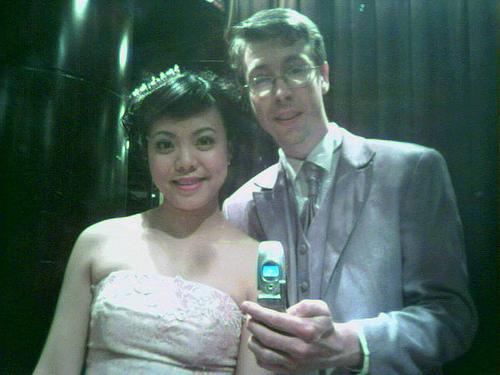What is the man using the phone to do? Please explain your reasoning. take picture. They are taking a selfie in a mirror 